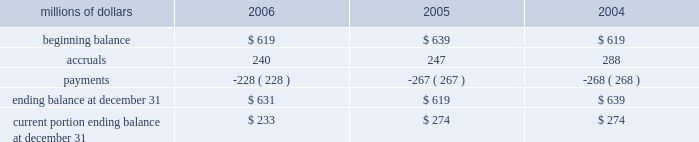Consolidated results of operations , financial condition , or liquidity ; however , to the extent possible , where unasserted claims are considered probable and where such claims can be reasonably estimated , we have recorded a liability .
We do not expect that any known lawsuits , claims , environmental costs , commitments , contingent liabilities , or guarantees will have a material adverse effect on our consolidated results of operations , financial condition , or liquidity after taking into account liabilities previously recorded for these matters .
Personal injury 2013 the cost of personal injuries to employees and others related to our activities is charged to expense based on estimates of the ultimate cost and number of incidents each year .
We use third-party actuaries to assist us in measuring the expense and liability , including unasserted claims .
Compensation for work-related accidents is governed by the federal employers 2019 liability act ( fela ) .
Under fela , damages are assessed based on a finding of fault through litigation or out-of-court settlements .
Our personal injury liability activity was as follows : millions of dollars 2006 2005 2004 .
Our personal injury liability is discounted to present value using applicable u.s .
Treasury rates .
Approximately 87% ( 87 % ) of the recorded liability related to asserted claims , and approximately 13% ( 13 % ) related to unasserted claims .
Personal injury accruals were higher in 2004 due to a 1998 crossing accident verdict upheld in 2004 and a 2004 derailment near san antonio .
Asbestos 2013 we are a defendant in a number of lawsuits in which current and former employees allege exposure to asbestos .
Additionally , we have received claims for asbestos exposure that have not been litigated .
The claims and lawsuits ( collectively referred to as 201cclaims 201d ) allege occupational illness resulting from exposure to asbestos- containing products .
In most cases , the claimants do not have credible medical evidence of physical impairment resulting from the alleged exposures .
Additionally , most claims filed against us do not specify an amount of alleged damages .
During 2004 , we engaged a third party with extensive experience in estimating resolution costs for asbestos- related claims to assist us in assessing the number and value of these unasserted claims through 2034 , based on our average claims experience over a multi-year period .
As a result , we increased our liability in 2004 for asbestos- related claims in the fourth quarter of 2004 .
The liability for resolving both asserted and unasserted claims was based on the following assumptions : 2022 the number of future claims received would be consistent with historical averages .
2022 the number of claims filed against us will decline each year .
2022 the average settlement values for asserted and unasserted claims will be equivalent to historical averages .
2022 the percentage of claims dismissed in the future will be equivalent to historical averages. .
What was the percentage change in personal injury liability from 2004 to 2005? 
Computations: ((619 - 639) / 639)
Answer: -0.0313. 